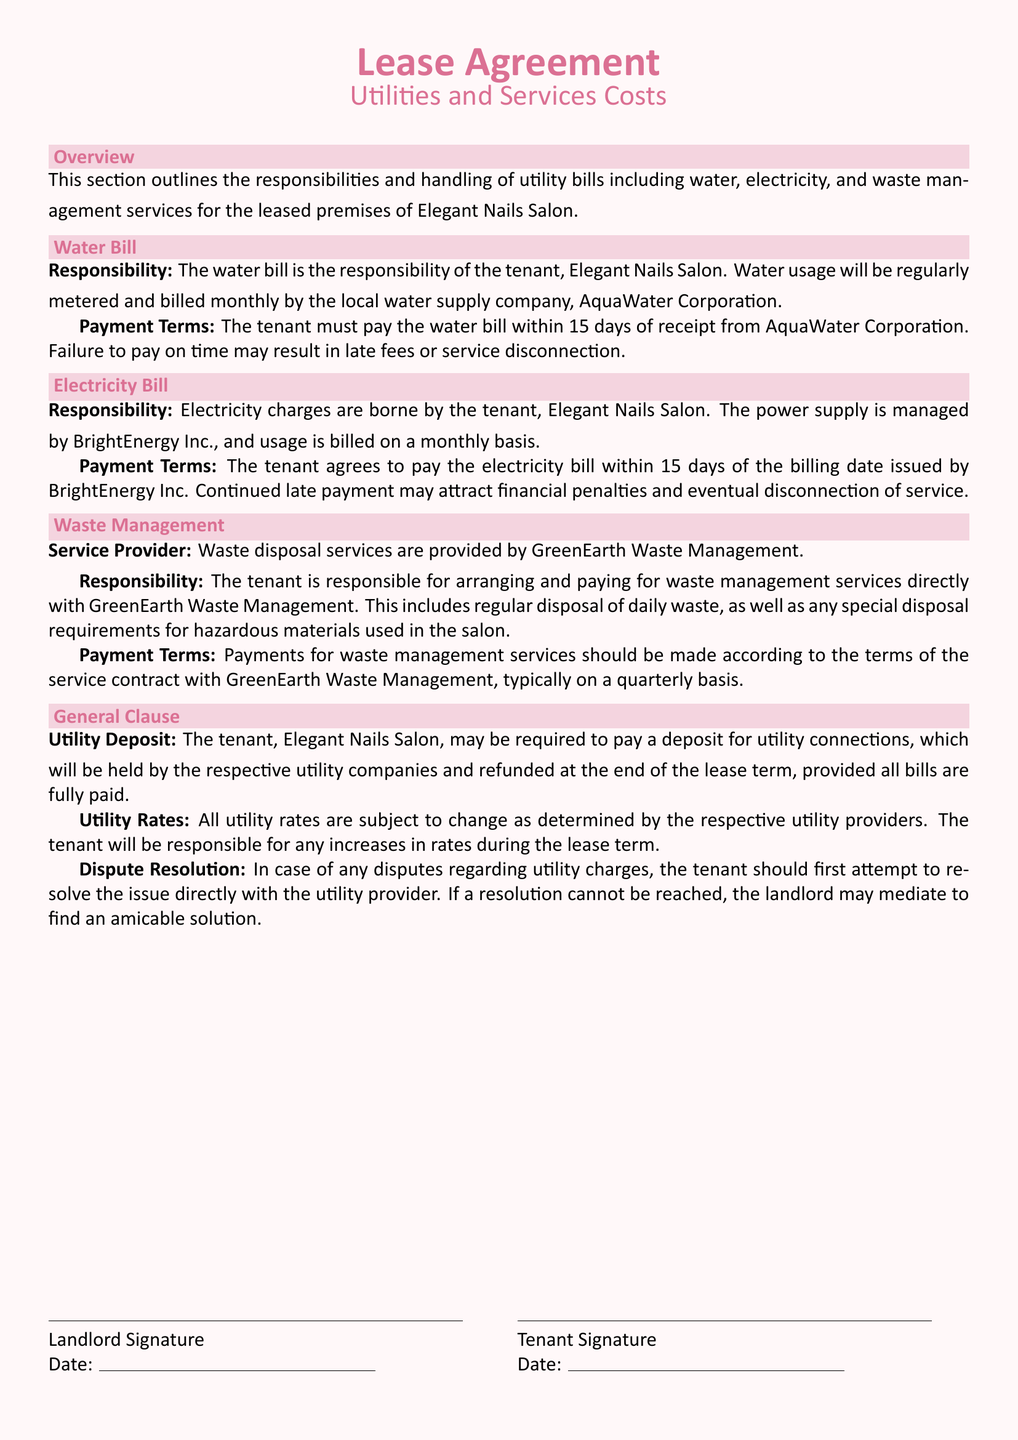What is the name of the water supply company? The water bill is managed by AquaWater Corporation.
Answer: AquaWater Corporation Who is responsible for the electricity charges? The tenant, Elegant Nails Salon, is responsible for the electricity charges.
Answer: Elegant Nails Salon How often are electricity bills issued? The electricity usage is billed on a monthly basis.
Answer: Monthly What is the payment deadline for the water bill? The tenant must pay the water bill within 15 days of receipt.
Answer: 15 days Who provides the waste management services? Waste management services are provided by GreenEarth Waste Management.
Answer: GreenEarth Waste Management What happens in case of late payment for electricity? Continued late payment may attract financial penalties and service disconnection.
Answer: Financial penalties What type of materials may require special disposal? Hazardous materials used in the salon may require special disposal.
Answer: Hazardous materials What is the general utility deposit policy mentioned? The tenant may be required to pay a deposit, which will be refunded at the end of the lease.
Answer: Refundable deposit How frequently should waste management services be paid for? Payments for waste management services are typically made on a quarterly basis.
Answer: Quarterly What should a tenant do in case of a dispute regarding utility charges? The tenant should first attempt to resolve the issue directly with the utility provider.
Answer: Resolve with provider 